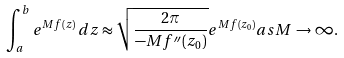<formula> <loc_0><loc_0><loc_500><loc_500>\int _ { a } ^ { b } e ^ { M f ( z ) } \, d z \approx { \sqrt { \frac { 2 \pi } { - M f ^ { \prime \prime } ( z _ { 0 } ) } } } e ^ { M f ( z _ { 0 } ) } { a s } M \to \infty .</formula> 